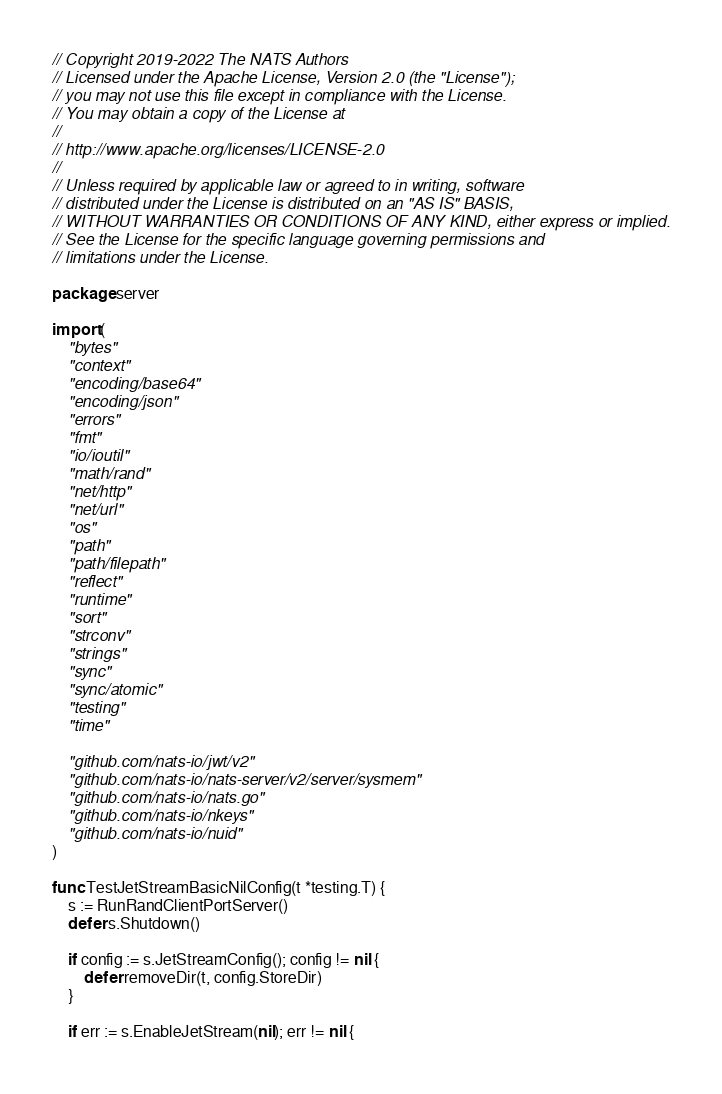Convert code to text. <code><loc_0><loc_0><loc_500><loc_500><_Go_>// Copyright 2019-2022 The NATS Authors
// Licensed under the Apache License, Version 2.0 (the "License");
// you may not use this file except in compliance with the License.
// You may obtain a copy of the License at
//
// http://www.apache.org/licenses/LICENSE-2.0
//
// Unless required by applicable law or agreed to in writing, software
// distributed under the License is distributed on an "AS IS" BASIS,
// WITHOUT WARRANTIES OR CONDITIONS OF ANY KIND, either express or implied.
// See the License for the specific language governing permissions and
// limitations under the License.

package server

import (
	"bytes"
	"context"
	"encoding/base64"
	"encoding/json"
	"errors"
	"fmt"
	"io/ioutil"
	"math/rand"
	"net/http"
	"net/url"
	"os"
	"path"
	"path/filepath"
	"reflect"
	"runtime"
	"sort"
	"strconv"
	"strings"
	"sync"
	"sync/atomic"
	"testing"
	"time"

	"github.com/nats-io/jwt/v2"
	"github.com/nats-io/nats-server/v2/server/sysmem"
	"github.com/nats-io/nats.go"
	"github.com/nats-io/nkeys"
	"github.com/nats-io/nuid"
)

func TestJetStreamBasicNilConfig(t *testing.T) {
	s := RunRandClientPortServer()
	defer s.Shutdown()

	if config := s.JetStreamConfig(); config != nil {
		defer removeDir(t, config.StoreDir)
	}

	if err := s.EnableJetStream(nil); err != nil {</code> 